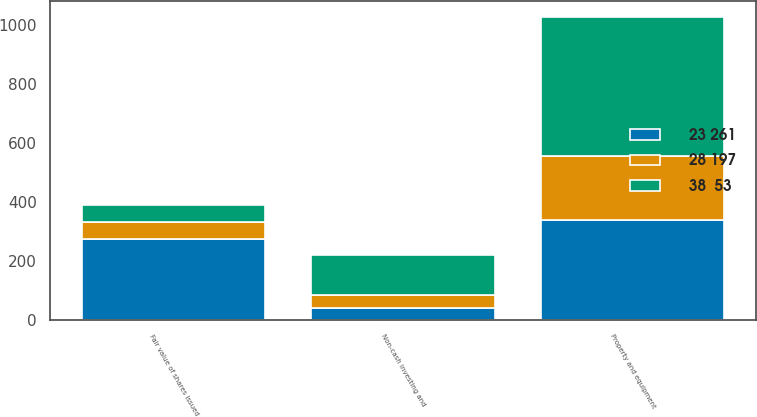Convert chart. <chart><loc_0><loc_0><loc_500><loc_500><stacked_bar_chart><ecel><fcel>Non-cash investing and<fcel>Property and equipment<fcel>Fair value of shares issued<nl><fcel>23 261<fcel>40<fcel>340<fcel>274<nl><fcel>38  53<fcel>135<fcel>473<fcel>58<nl><fcel>28 197<fcel>47<fcel>217<fcel>60<nl></chart> 